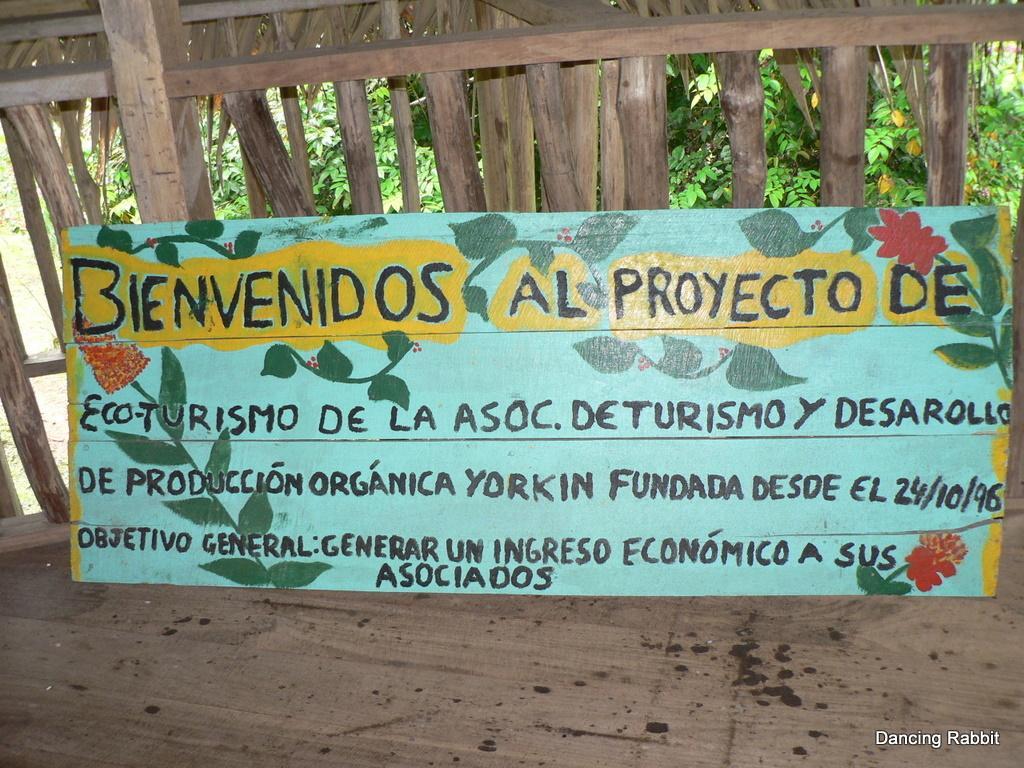How would you summarize this image in a sentence or two? In the image there is a board with some text on it on a wooden floor, behind it there are trees,plants on the backside of the wall. 